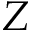<formula> <loc_0><loc_0><loc_500><loc_500>Z</formula> 